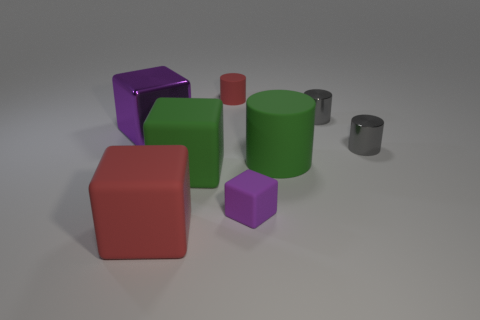The tiny gray cylinder behind the gray cylinder in front of the tiny metallic object that is behind the large purple cube is made of what material?
Make the answer very short. Metal. Is the number of big purple cubes behind the big purple block the same as the number of tiny brown spheres?
Provide a succinct answer. Yes. Are the purple object that is in front of the purple metallic thing and the cube that is behind the big green matte cylinder made of the same material?
Your answer should be compact. No. Is the shape of the matte object that is in front of the small rubber block the same as the purple object that is in front of the large purple thing?
Keep it short and to the point. Yes. Is the number of small cylinders that are behind the red cylinder less than the number of matte cubes?
Your response must be concise. Yes. How many rubber objects have the same color as the large cylinder?
Keep it short and to the point. 1. There is a purple cube that is to the left of the large red rubber block; what size is it?
Offer a very short reply. Large. The gray object on the right side of the small metal cylinder behind the metal thing on the left side of the large rubber cylinder is what shape?
Offer a terse response. Cylinder. What shape is the object that is both on the left side of the green cube and right of the metal block?
Provide a short and direct response. Cube. Is there a red rubber ball that has the same size as the green rubber cylinder?
Your answer should be very brief. No. 